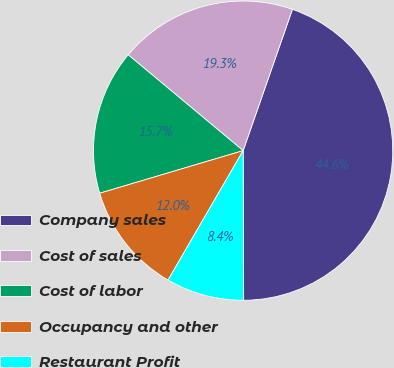Convert chart to OTSL. <chart><loc_0><loc_0><loc_500><loc_500><pie_chart><fcel>Company sales<fcel>Cost of sales<fcel>Cost of labor<fcel>Occupancy and other<fcel>Restaurant Profit<nl><fcel>44.61%<fcel>19.28%<fcel>15.66%<fcel>12.04%<fcel>8.42%<nl></chart> 